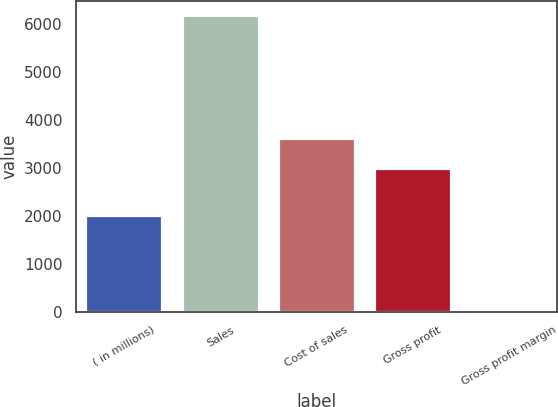<chart> <loc_0><loc_0><loc_500><loc_500><bar_chart><fcel>( in millions)<fcel>Sales<fcel>Cost of sales<fcel>Gross profit<fcel>Gross profit margin<nl><fcel>2015<fcel>6178.8<fcel>3613.02<fcel>3000<fcel>48.6<nl></chart> 